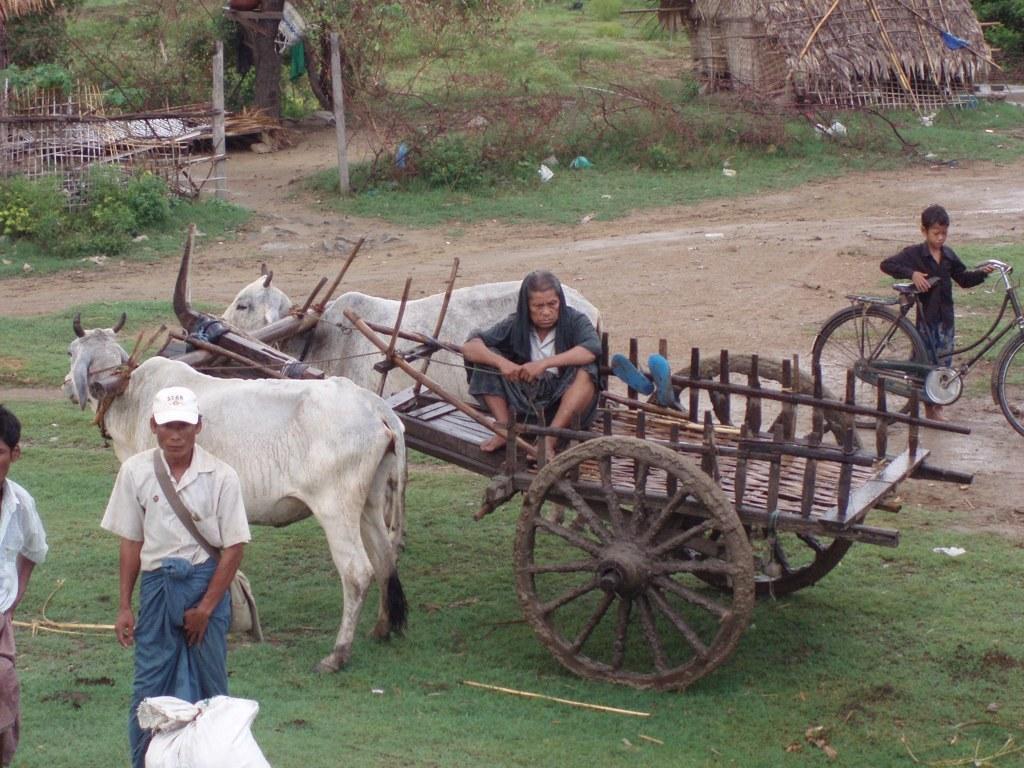Can you describe this image briefly? In this image in the center there is one vehicle and two cows, and at the bottom there is grass and some persons are standing and in the background there are some houses, trees and wooden sticks. In the center there is a walk, on the right side there is one boy who is holding a cycle. 